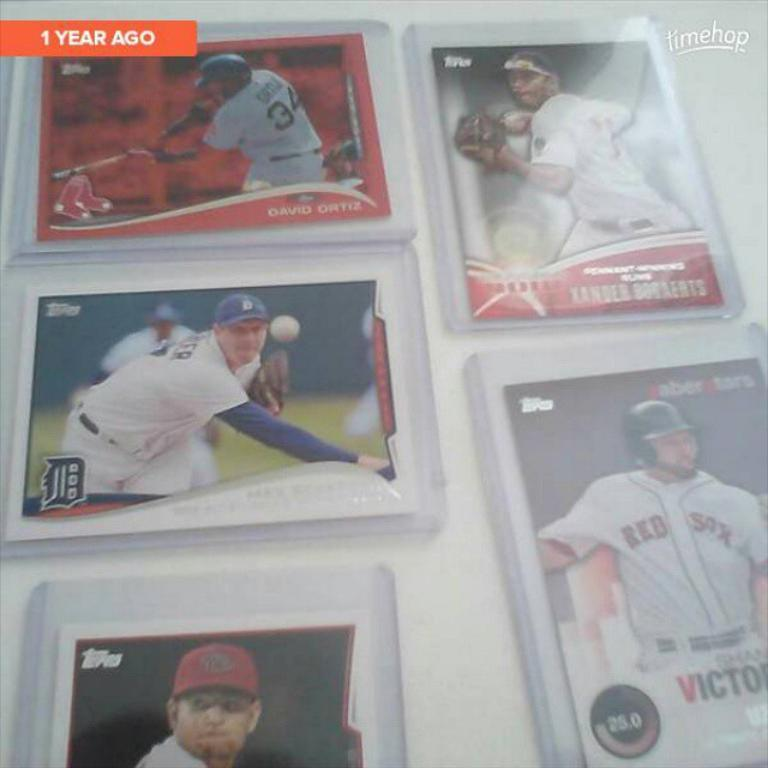What is hanging on the wall in the image? There are photos of persons on the wall in the image. Can you describe the content of the photos? The photos depict persons, but the specific details of the individuals cannot be determined from the image alone. Are there any other decorations or objects on the wall in the image? The provided facts do not mention any other decorations or objects on the wall. What type of fish can be seen swimming in the image? There is no fish present in the image; it features photos of persons on the wall. 